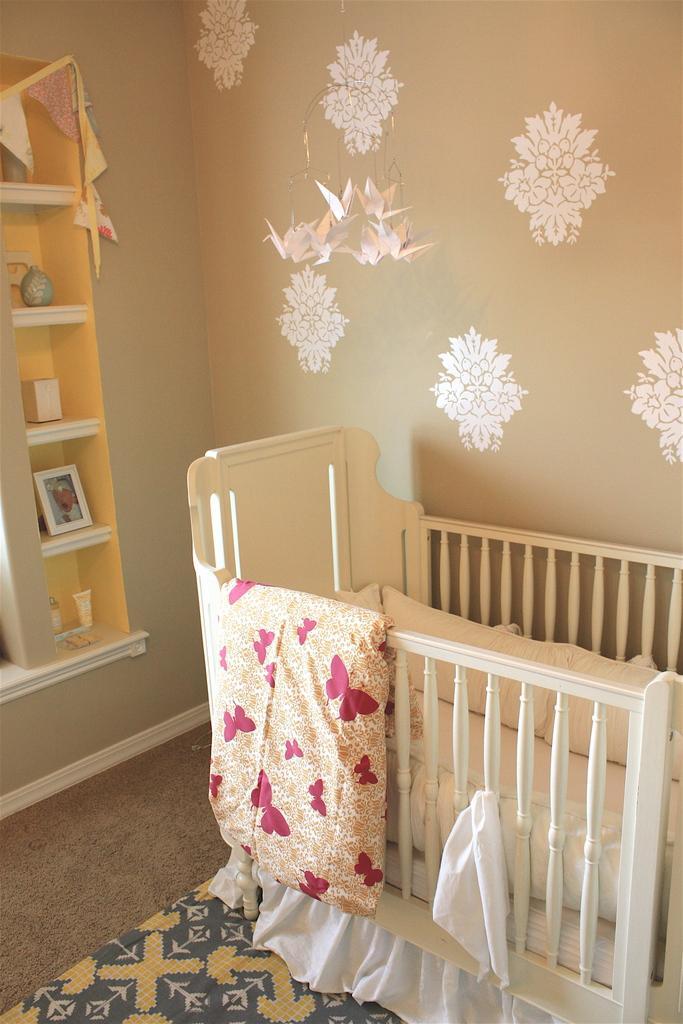In one or two sentences, can you explain what this image depicts? In the image there is an infant bed and behind the bed there is a wall and there are some shelves to the cabinet in front of the wall. 